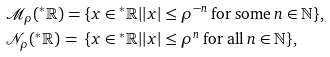<formula> <loc_0><loc_0><loc_500><loc_500>& \mathcal { M } _ { \rho } ( ^ { * } \mathbb { R } ) = \{ x \in { ^ { * } \mathbb { R } } | | x | \leq \rho ^ { - n } \text {\,for some\,} n \in \mathbb { N } \} , \\ & \mathcal { N } _ { \rho } ( ^ { * } \mathbb { R } ) \, = \, \{ x \in { ^ { * } \mathbb { R } } | | x | \leq \rho ^ { n } \text {\,for all\,} n \in \mathbb { N } \} ,</formula> 